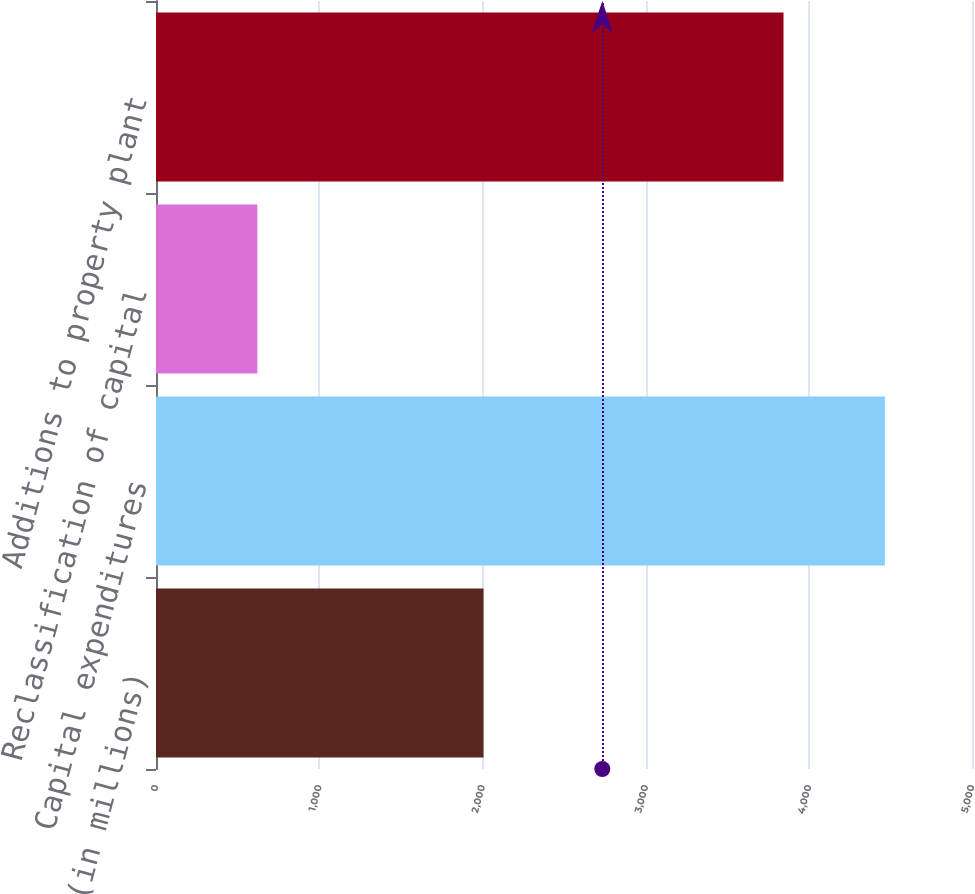Convert chart to OTSL. <chart><loc_0><loc_0><loc_500><loc_500><bar_chart><fcel>(in millions)<fcel>Capital expenditures<fcel>Reclassification of capital<fcel>Additions to property plant<nl><fcel>2007<fcel>4466<fcel>621<fcel>3845<nl></chart> 